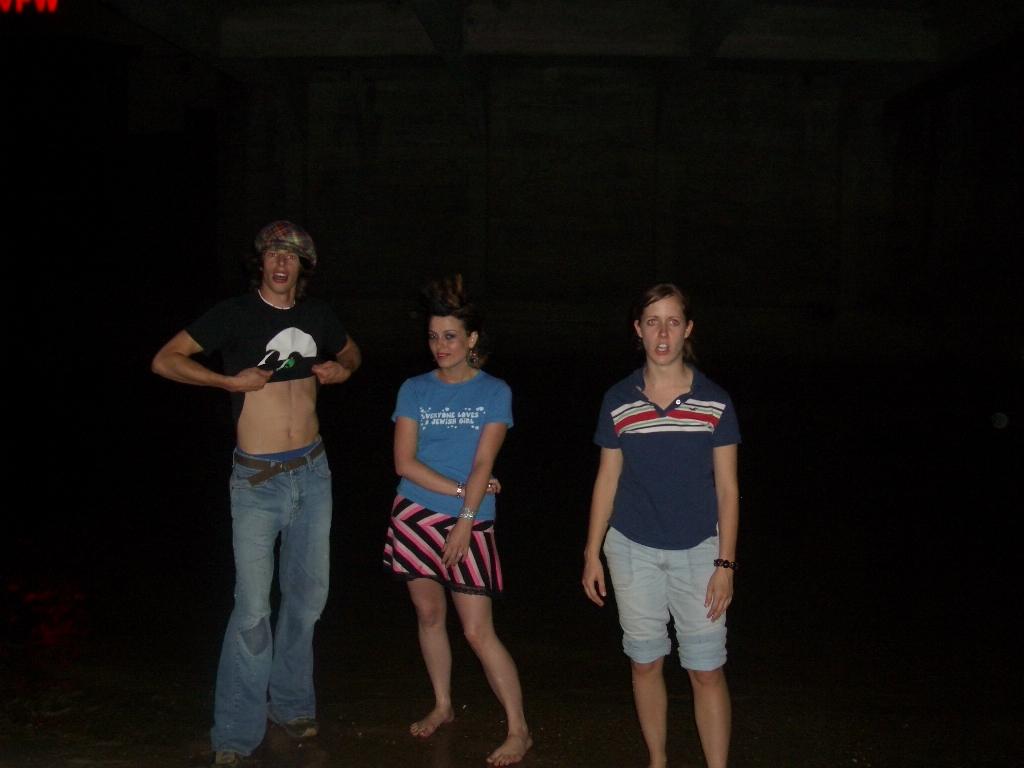What does the girl's shirt in the middle say?
Offer a terse response. Everyone loves a jewish girl. 